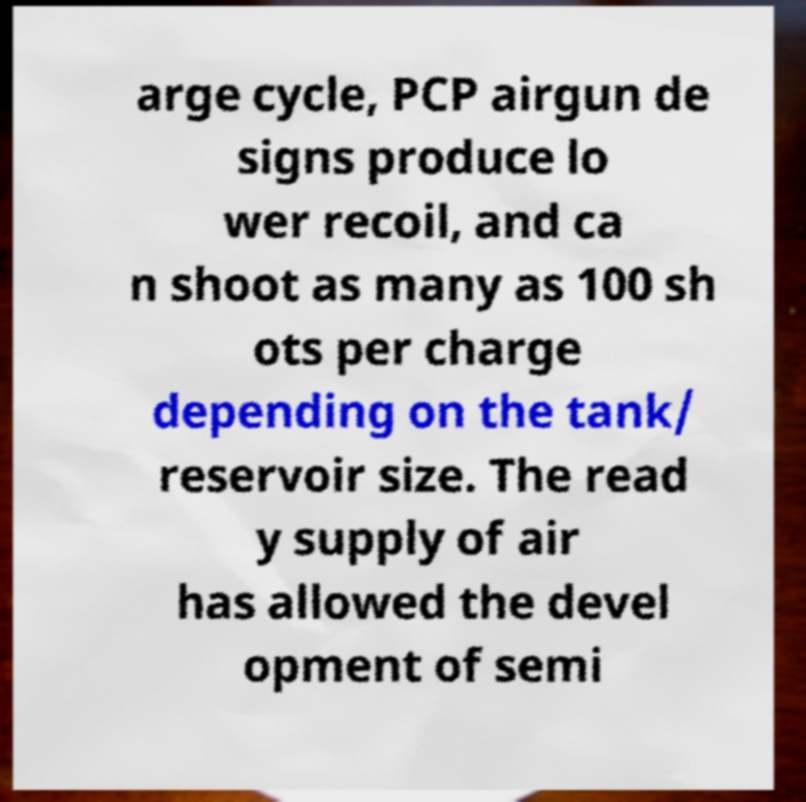Could you assist in decoding the text presented in this image and type it out clearly? arge cycle, PCP airgun de signs produce lo wer recoil, and ca n shoot as many as 100 sh ots per charge depending on the tank/ reservoir size. The read y supply of air has allowed the devel opment of semi 